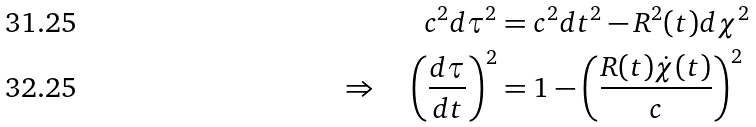<formula> <loc_0><loc_0><loc_500><loc_500>c ^ { 2 } d \tau ^ { 2 } & = c ^ { 2 } d t ^ { 2 } - R ^ { 2 } ( t ) d \chi ^ { 2 } \\ \Rightarrow \quad \left ( \frac { d \tau } { d t } \right ) ^ { 2 } & = 1 - \left ( \frac { R ( t ) \dot { \chi } ( t ) } { c } \right ) ^ { 2 }</formula> 